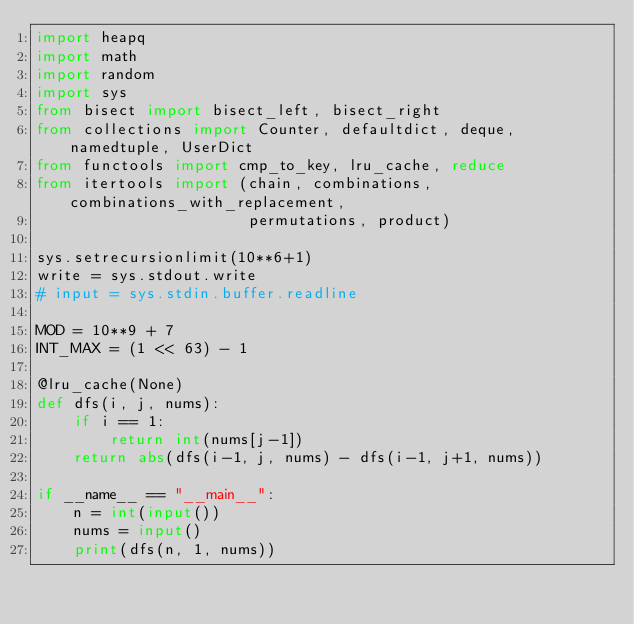Convert code to text. <code><loc_0><loc_0><loc_500><loc_500><_Python_>import heapq
import math
import random
import sys
from bisect import bisect_left, bisect_right
from collections import Counter, defaultdict, deque, namedtuple, UserDict
from functools import cmp_to_key, lru_cache, reduce
from itertools import (chain, combinations, combinations_with_replacement,
                       permutations, product)

sys.setrecursionlimit(10**6+1)
write = sys.stdout.write
# input = sys.stdin.buffer.readline

MOD = 10**9 + 7
INT_MAX = (1 << 63) - 1

@lru_cache(None)
def dfs(i, j, nums):
    if i == 1:
        return int(nums[j-1])
    return abs(dfs(i-1, j, nums) - dfs(i-1, j+1, nums))

if __name__ == "__main__":
    n = int(input())
    nums = input()
    print(dfs(n, 1, nums))

</code> 